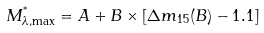Convert formula to latex. <formula><loc_0><loc_0><loc_500><loc_500>M _ { \lambda , \max } ^ { ^ { * } } = A + B \times [ \Delta m _ { 1 5 } ( B ) - 1 . 1 ]</formula> 